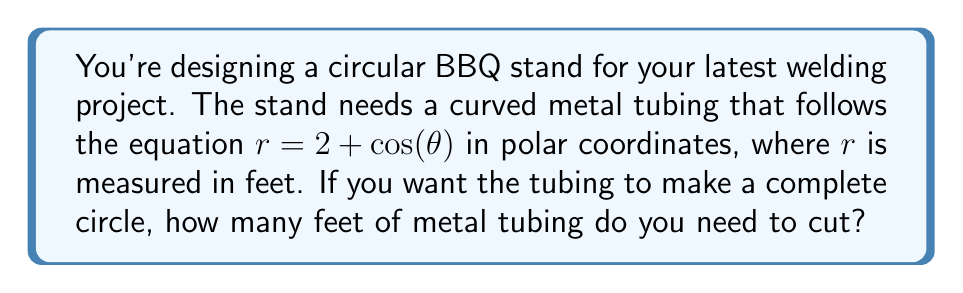Provide a solution to this math problem. To solve this problem, we need to use the arc length formula for polar curves. The formula is:

$$L = \int_a^b \sqrt{r^2 + \left(\frac{dr}{d\theta}\right)^2} d\theta$$

Where $L$ is the arc length, $r$ is the polar function, and $a$ and $b$ are the starting and ending angles respectively.

Given:
$r = 2 + \cos(\theta)$

Step 1: Find $\frac{dr}{d\theta}$
$$\frac{dr}{d\theta} = -\sin(\theta)$$

Step 2: Substitute into the arc length formula
$$L = \int_0^{2\pi} \sqrt{(2 + \cos(\theta))^2 + (-\sin(\theta))^2} d\theta$$

Step 3: Simplify the expression under the square root
$$(2 + \cos(\theta))^2 + \sin^2(\theta) = 4 + 4\cos(\theta) + \cos^2(\theta) + \sin^2(\theta)$$
$$= 4 + 4\cos(\theta) + 1 = 5 + 4\cos(\theta)$$

Step 4: Rewrite the integral
$$L = \int_0^{2\pi} \sqrt{5 + 4\cos(\theta)} d\theta$$

Step 5: This integral doesn't have an elementary antiderivative, so we need to use numerical integration methods to approximate the result. Using a computer algebra system or numerical integration tool, we find:

$$L \approx 14.3841 \text{ feet}$$

[asy]
import graph;
size(200);
real r(real t) {return 2+cos(t);}
path g=polargraph(r,0,2pi);
draw(g,blue);
xaxis("x",Arrow);
yaxis("y",Arrow);
label("$r=2+\cos(\theta)$",(3,1),E);
[/asy]
Answer: The length of curved metal tubing needed for the circular BBQ stand is approximately 14.38 feet. 